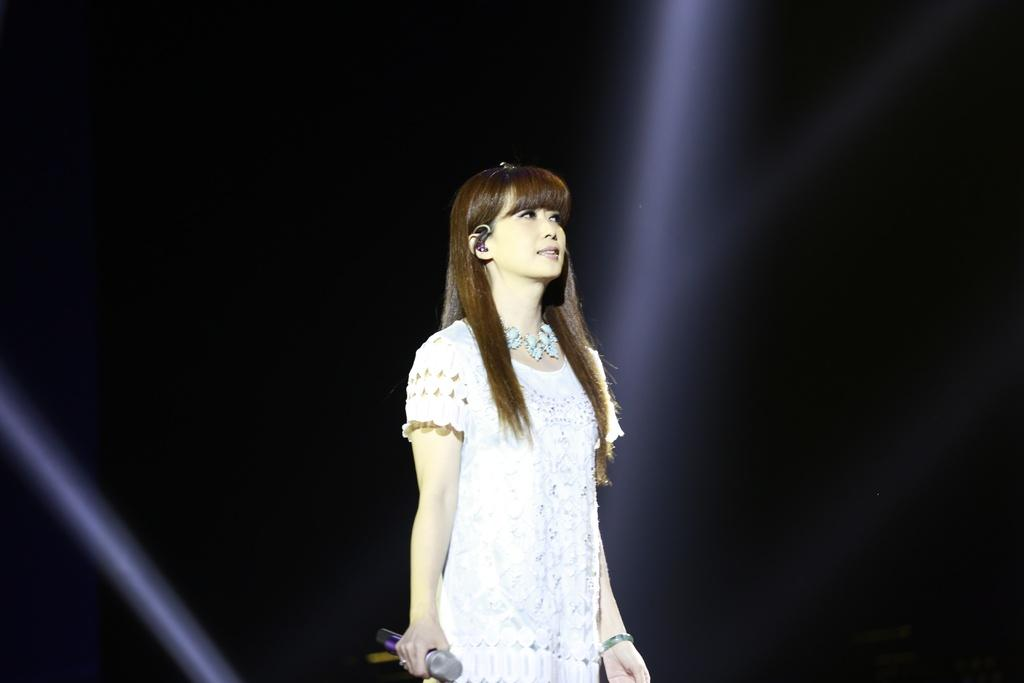Who is the main subject in the image? There is a woman in the image. What is the woman doing in the image? The woman is standing in the image. What object is the woman holding in the image? The woman is holding a mic in the image. What type of vacation is the woman planning in the image? There is no indication of a vacation in the image; the woman is simply standing and holding a mic. 